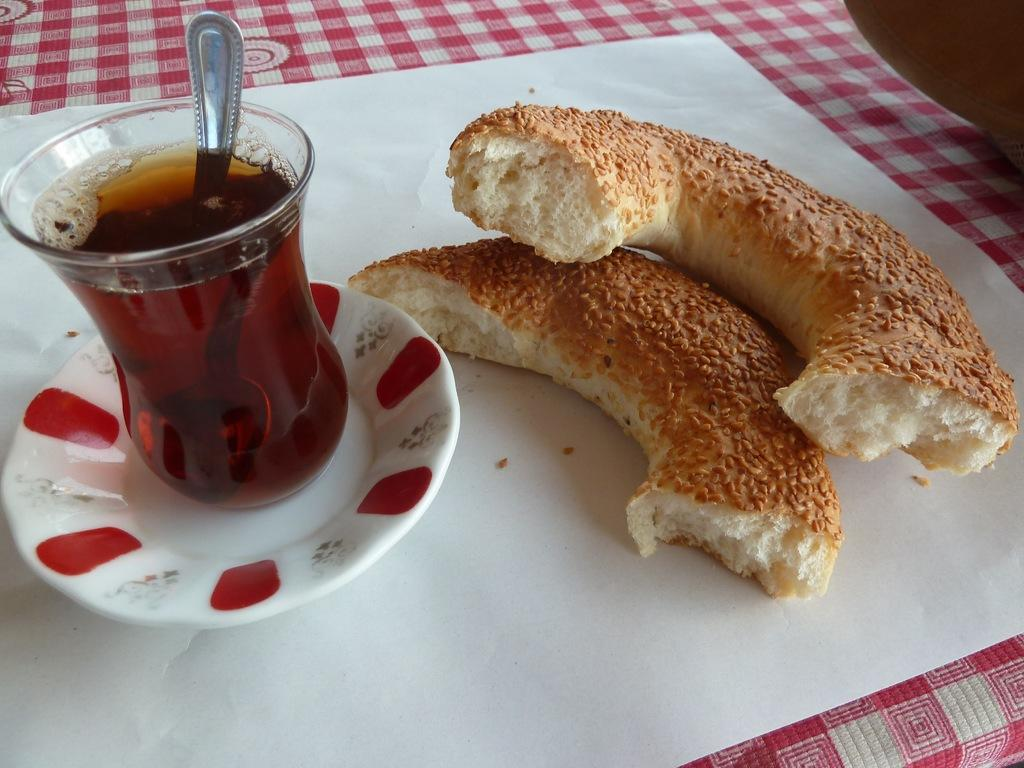What is located on the left side of the image? There is a glass with liquid in it and a spoon on the left side of the image. What can be seen on the right side of the image? There are food items on the right side of the image. What type of vest is being worn by the oatmeal in the image? There is no oatmeal or vest present in the image. What emotion is the food feeling in the image? The food does not have emotions, so it cannot feel shame or any other emotion. 